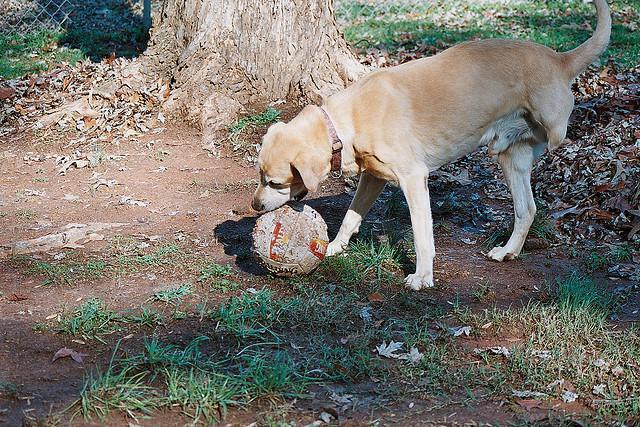How many dogs in the shot?
Give a very brief answer. 1. How many blue keyboards are there?
Give a very brief answer. 0. 